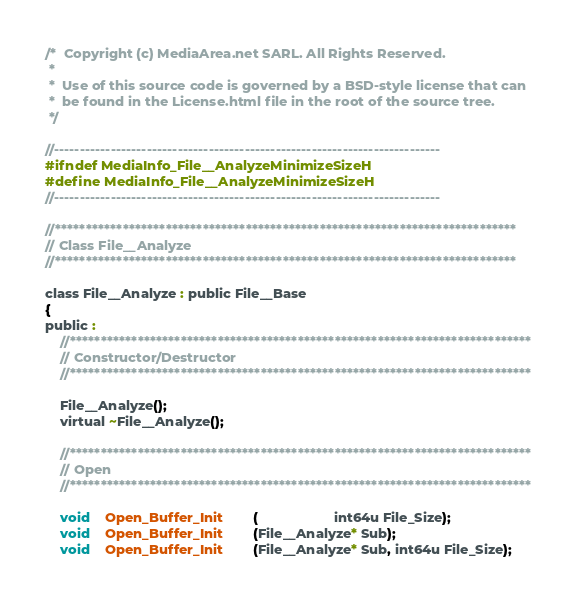<code> <loc_0><loc_0><loc_500><loc_500><_C_>/*  Copyright (c) MediaArea.net SARL. All Rights Reserved.
 *
 *  Use of this source code is governed by a BSD-style license that can
 *  be found in the License.html file in the root of the source tree.
 */

//---------------------------------------------------------------------------
#ifndef MediaInfo_File__AnalyzeMinimizeSizeH
#define MediaInfo_File__AnalyzeMinimizeSizeH
//---------------------------------------------------------------------------

//***************************************************************************
// Class File__Analyze
//***************************************************************************

class File__Analyze : public File__Base
{
public :
    //***************************************************************************
    // Constructor/Destructor
    //***************************************************************************

    File__Analyze();
    virtual ~File__Analyze();

    //***************************************************************************
    // Open
    //***************************************************************************

    void    Open_Buffer_Init        (                    int64u File_Size);
    void    Open_Buffer_Init        (File__Analyze* Sub);
    void    Open_Buffer_Init        (File__Analyze* Sub, int64u File_Size);</code> 